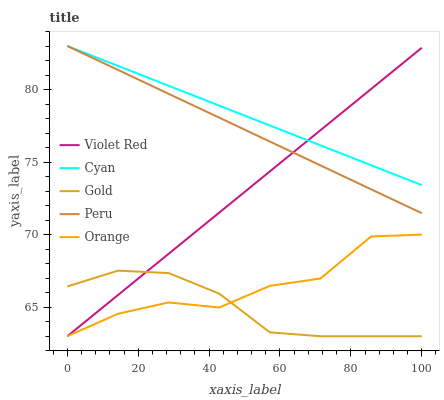Does Gold have the minimum area under the curve?
Answer yes or no. Yes. Does Cyan have the maximum area under the curve?
Answer yes or no. Yes. Does Violet Red have the minimum area under the curve?
Answer yes or no. No. Does Violet Red have the maximum area under the curve?
Answer yes or no. No. Is Violet Red the smoothest?
Answer yes or no. Yes. Is Orange the roughest?
Answer yes or no. Yes. Is Cyan the smoothest?
Answer yes or no. No. Is Cyan the roughest?
Answer yes or no. No. Does Orange have the lowest value?
Answer yes or no. Yes. Does Cyan have the lowest value?
Answer yes or no. No. Does Peru have the highest value?
Answer yes or no. Yes. Does Violet Red have the highest value?
Answer yes or no. No. Is Gold less than Peru?
Answer yes or no. Yes. Is Cyan greater than Gold?
Answer yes or no. Yes. Does Gold intersect Orange?
Answer yes or no. Yes. Is Gold less than Orange?
Answer yes or no. No. Is Gold greater than Orange?
Answer yes or no. No. Does Gold intersect Peru?
Answer yes or no. No. 